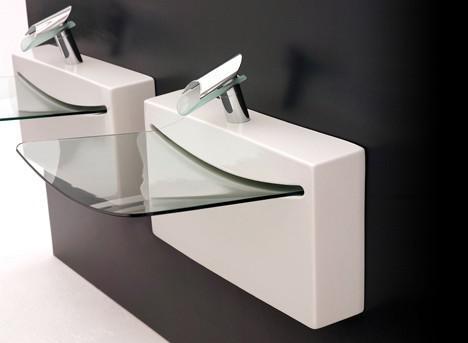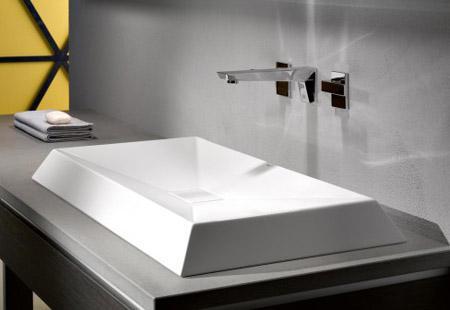The first image is the image on the left, the second image is the image on the right. Analyze the images presented: Is the assertion "One wash basin currently contains water." valid? Answer yes or no. No. The first image is the image on the left, the second image is the image on the right. Evaluate the accuracy of this statement regarding the images: "The sink on the right has a somewhat spiral shape and has a spout mounted on the wall above it, and the counter-top sink on the left is white and rounded with a silver spout over the basin.". Is it true? Answer yes or no. No. 